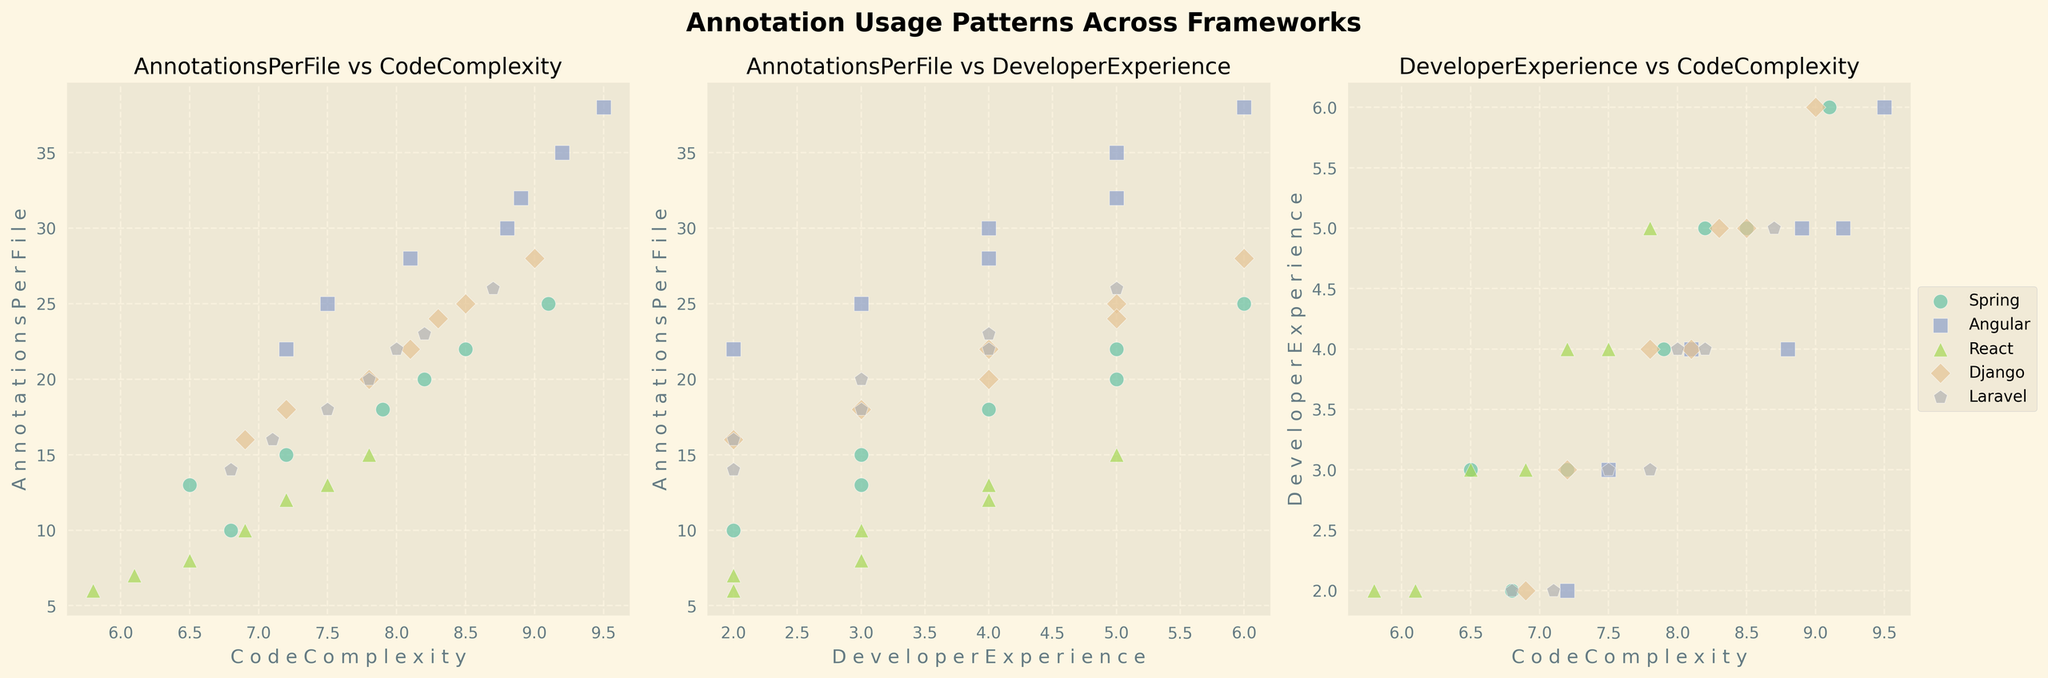Which framework shows the highest number of annotations per file? In the scatter plot of 'CodeComplexity' vs 'AnnotationsPerFile', the framework with annotations per file greatest value on the y-axis represents the highest annotations. By observing, Angular has data points reaching up to 38 annotations per file.
Answer: Angular Which two frameworks appear to have similar patterns in 'DeveloperExperience' versus 'AnnotationsPerFile'? In the scatter plot of 'DeveloperExperience' vs 'AnnotationsPerFile', we observe clustering and overlap patterns. Spring and Django generally have similar clustering patterns, where data points are spread relatively uniformly across 'AnnotationsPerFile' values while growing slightly with experience.
Answer: Spring and Django What is the average code complexity value for Angular? In the subplot 'AnnotationsPerFile vs CodeComplexity', the x-axis provides code complexity values. For Angular data points, calculate the average of complexity values: (8.8 + 7.5 + 9.2 + 8.1 + 8.9 + 7.2 + 9.5) / 7. Add these values and divide by 7.
Answer: 8.456 Which framework has the lowest code complexity among the data points provided? In the scatter plot of 'AnnotationsPerFile' vs 'CodeComplexity', the framework with the smallest value on the x-axis represents the lowest code complexity. React has a data point with a code complexity value of 5.8.
Answer: React How do Spring and Laravel compare in terms of average developer experience? In the subplot 'DeveloperExperience vs AnnotationsPerFile', observe the range of developer experiences. Compute the average for both: Spring (3+5+2+4+6+3+5) / 7 = 4, Laravel (3+4+2+3+5+2+4) / 7 = 3.2857. Spring has a slightly higher average developer experience compared to Laravel.
Answer: Spring has a higher average than Laravel Between Django and React, which has a higher median value for code complexity? To find the median code complexity for each framework, order the code complexity values and find the middle value. React: [5.8, 6.1, 6.5, 6.9, 7.2, 7.5, 7.8] (Median = 6.9), Django: [6.9, 7.2, 7.8, 8.1, 8.3, 8.5, 9.0] (Median = 8.1). Django has a higher median code complexity than React.
Answer: Django In the subplot 'AnnotationsPerFile vs CodeComplexity', which framework has a higher dispersion of annotations per file across its code complexity values? Dispersion refers to the spread of annotation points across the x-axis for each framework. Angular's annotations per file values range widely from about 22 to 38, across a similar range of code complexities, indicating higher dispersion.
Answer: Angular How do the annotations per file for React compare to those of Django? In the 'AnnotationsPerFile vs CodeComplexity' subplot, React's annotations per file range from about 6 to 15, while Django ranges from 16 to 28. Django generally has higher annotations per file in comparison to React.
Answer: Django has higher annotations per file Is there a positive correlation between code complexity and annotations per file for any framework? Positive correlation means both variables increase together. Observe the scatter plots for trends. Angular and Django show a generally positive trend where higher code complexity often coincides with more annotations per file, especially when looking at higher complexity values.
Answer: Yes, Angular and Django Which framework appears to have the most variable developer experience based on the scatter plot? In the 'CodeComplexity vs DeveloperExperience' subplot, greater vertical spread indicates more variability in developer experience. Laravel shows considerable spread from 2 to 5 in developer experience, indicating higher variability.
Answer: Laravel 